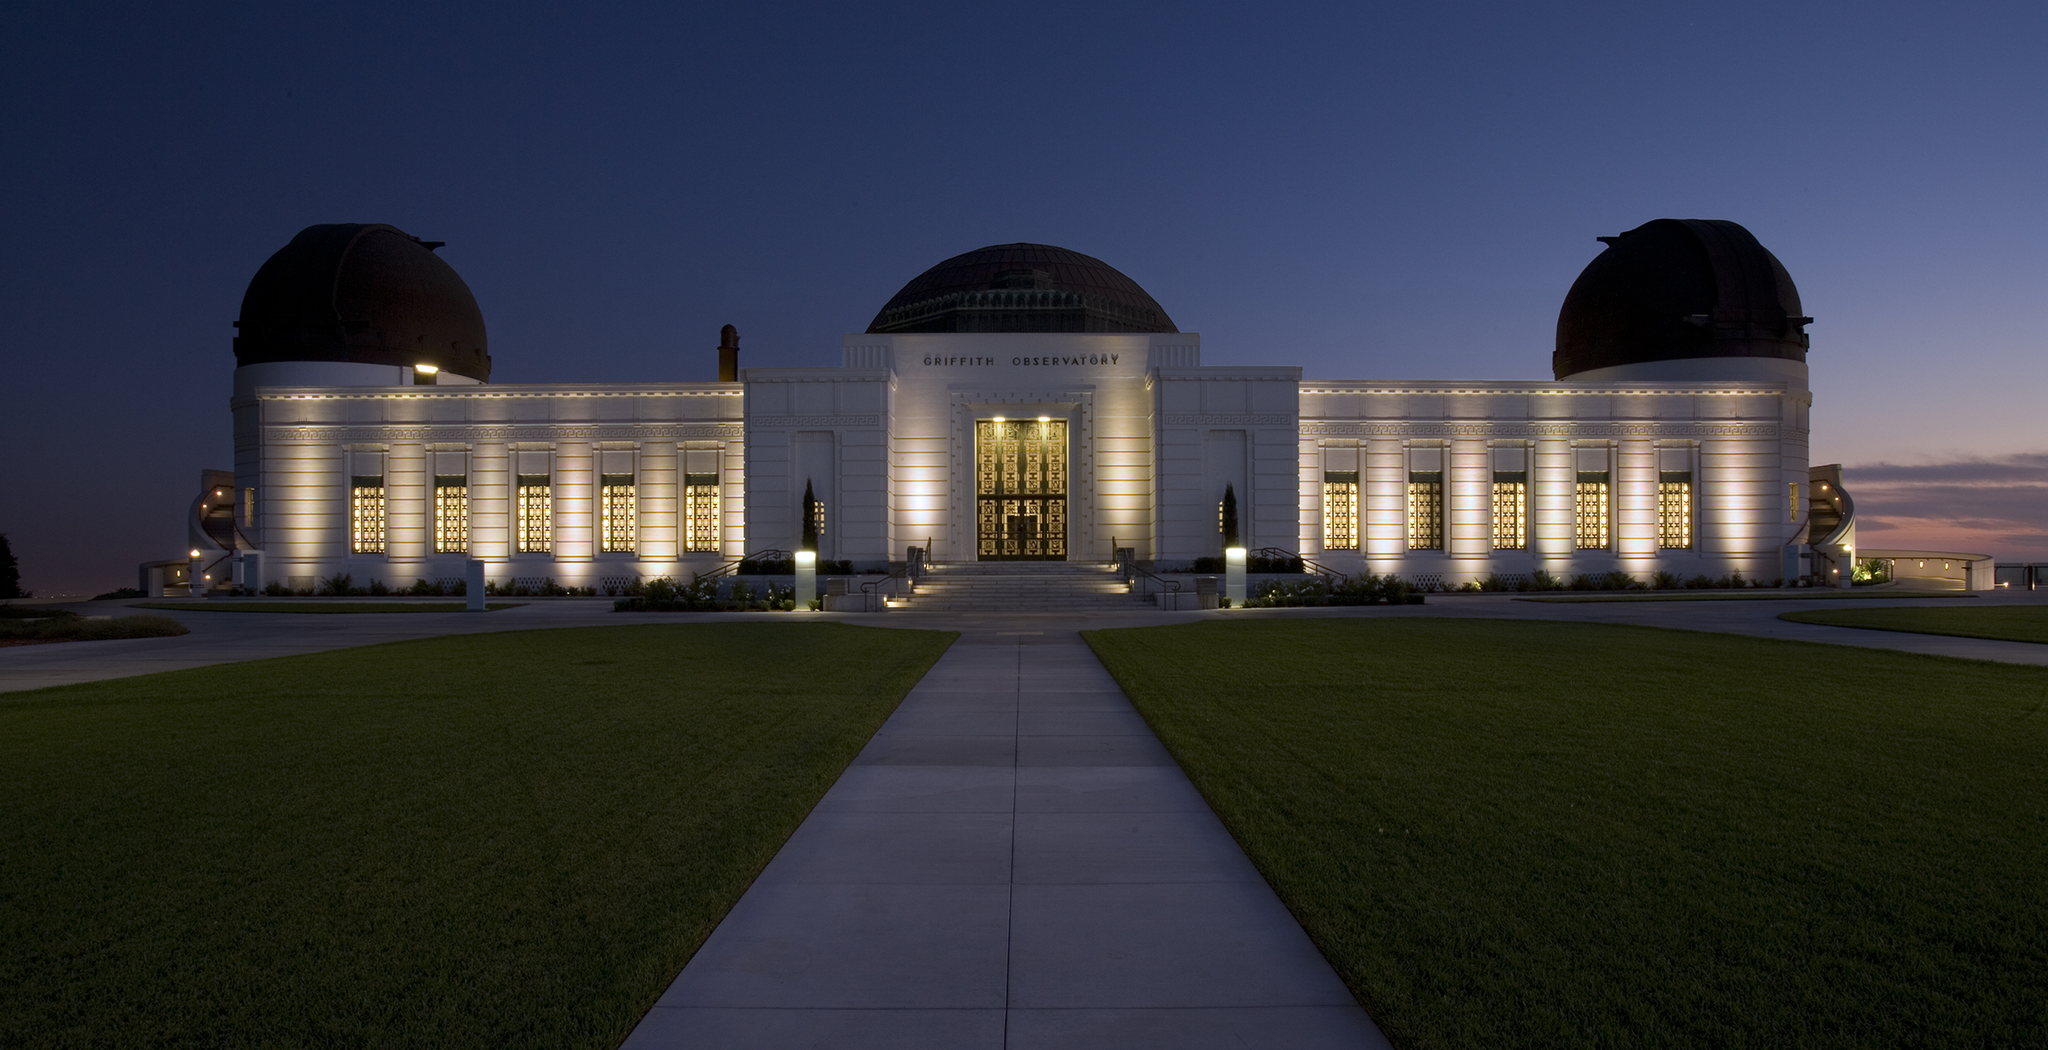Describe the atmosphere and mood of the scene. The atmosphere of the scene is one of tranquil elegance and serene beauty. As night begins to descend, the Griffith Observatory stands illuminated, its warm lights casting a gentle glow against the deepening twilight sky. The play of light and shadow creates a calm, almost mythical ambiance, inviting visitors to pause and admire the architectural marvel. The lush green lawn surrounding the observatory adds a refreshing contrast, enhancing the sense of serenity. The overall mood is peaceful and contemplative, a perfect setting for stargazing or simply enjoying a quiet evening. 